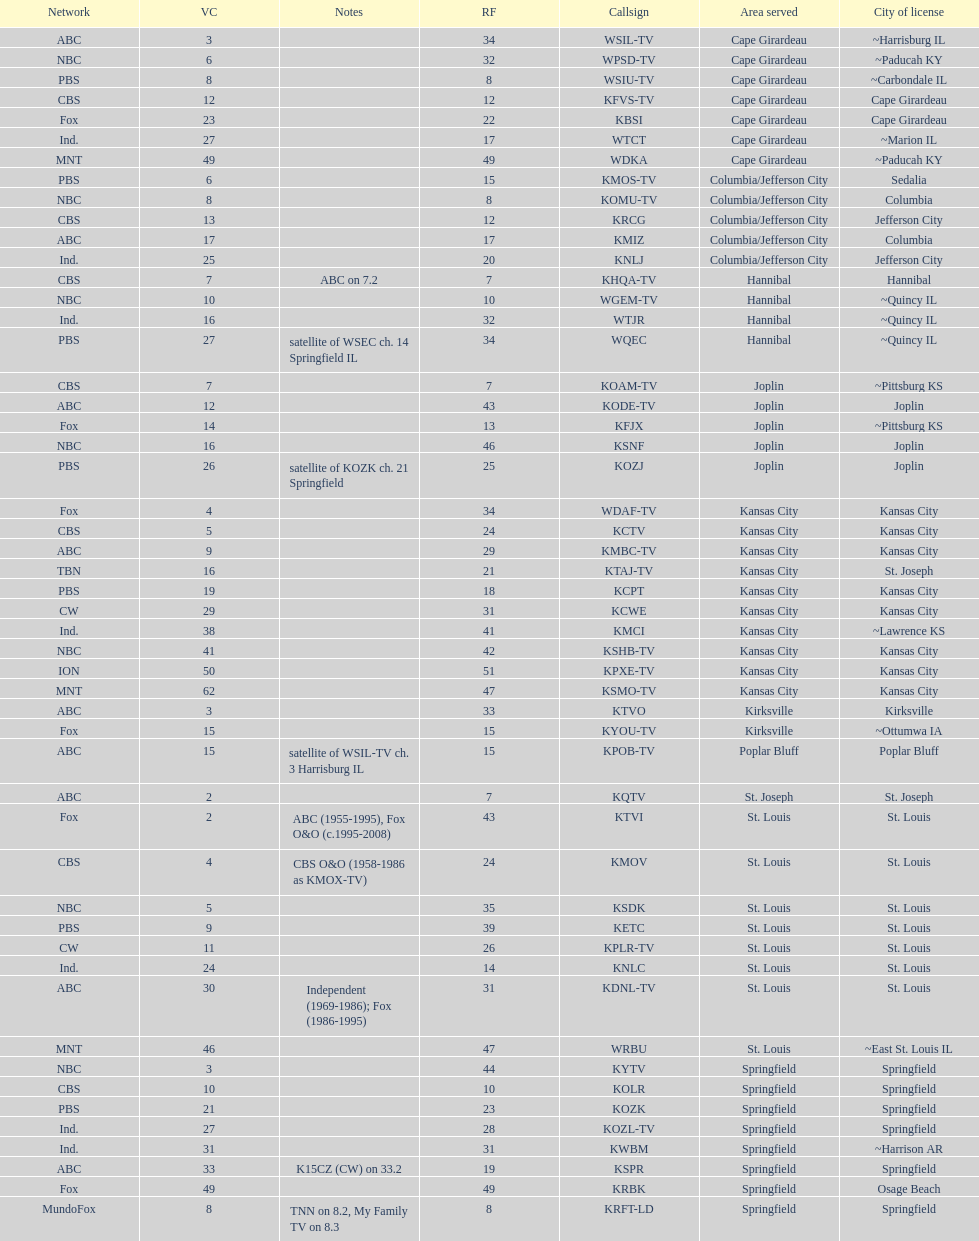What is the total number of cbs stations? 7. 